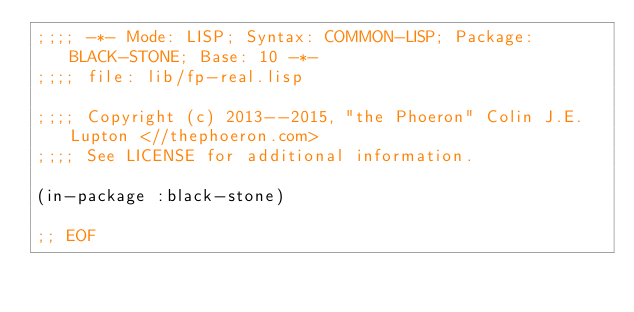<code> <loc_0><loc_0><loc_500><loc_500><_Lisp_>;;;; -*- Mode: LISP; Syntax: COMMON-LISP; Package: BLACK-STONE; Base: 10 -*-
;;;; file: lib/fp-real.lisp

;;;; Copyright (c) 2013--2015, "the Phoeron" Colin J.E. Lupton <//thephoeron.com>
;;;; See LICENSE for additional information.

(in-package :black-stone)

;; EOF
</code> 